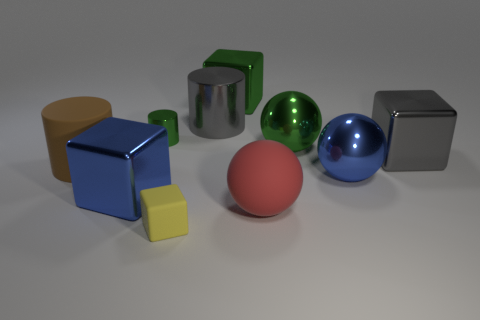If these objects represented data in a 3D chart, what could they possibly signify? If we interpret the objects as data points in a 3D chart, they could represent different variables and their magnitudes. For instance, the size of each object could represent the value of a particular data point, while the color could denote the category or group it belongs to. The different shapes might indicate different types of data or metrics being compared—cubes could stand for a set of related data, the cylinder might symbolize a different dataset, and the spheres could suggest correlation or connectivity between the data points they represent. 